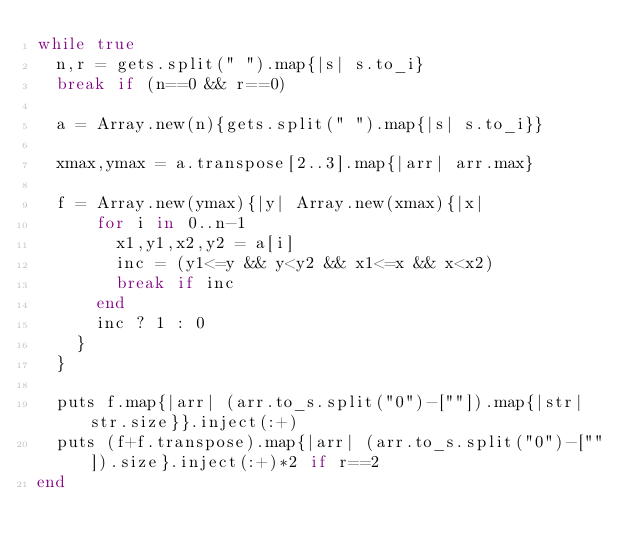<code> <loc_0><loc_0><loc_500><loc_500><_Ruby_>while true
  n,r = gets.split(" ").map{|s| s.to_i}
  break if (n==0 && r==0)
  
  a = Array.new(n){gets.split(" ").map{|s| s.to_i}}
  
  xmax,ymax = a.transpose[2..3].map{|arr| arr.max}

  f = Array.new(ymax){|y| Array.new(xmax){|x|
      for i in 0..n-1
        x1,y1,x2,y2 = a[i]
        inc = (y1<=y && y<y2 && x1<=x && x<x2)
        break if inc
      end
      inc ? 1 : 0
    }
  }

  puts f.map{|arr| (arr.to_s.split("0")-[""]).map{|str| str.size}}.inject(:+)
  puts (f+f.transpose).map{|arr| (arr.to_s.split("0")-[""]).size}.inject(:+)*2 if r==2
end</code> 